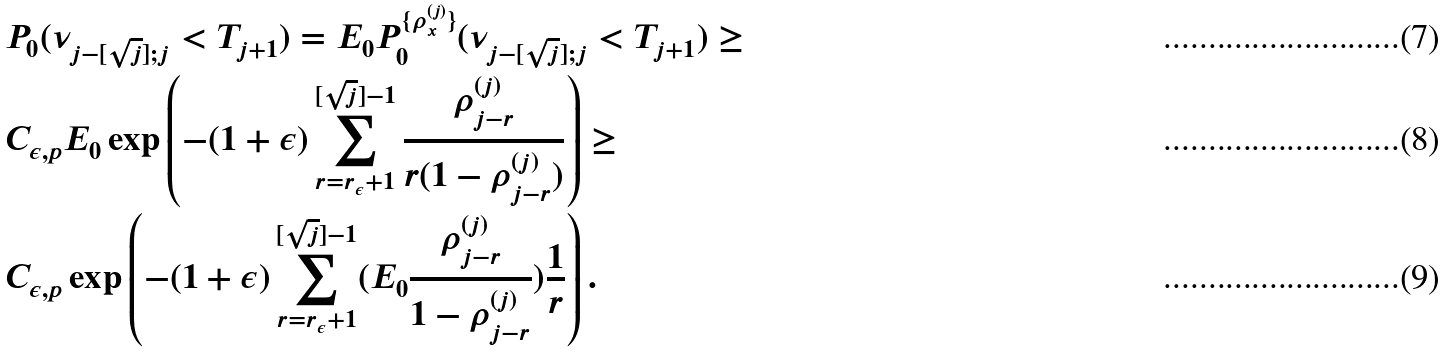<formula> <loc_0><loc_0><loc_500><loc_500>& P _ { 0 } ( \nu _ { j - [ \sqrt { j } ] ; j } < T _ { j + 1 } ) = E _ { 0 } P _ { 0 } ^ { \{ \rho _ { x } ^ { ( j ) } \} } ( \nu _ { j - [ \sqrt { j } ] ; j } < T _ { j + 1 } ) \geq \\ & C _ { \epsilon , p } E _ { 0 } \exp \left ( - ( 1 + \epsilon ) \sum _ { r = r _ { \epsilon } + 1 } ^ { [ \sqrt { j } ] - 1 } \frac { \rho _ { j - r } ^ { ( j ) } } { r ( 1 - \rho _ { j - r } ^ { ( j ) } ) } \right ) \geq \\ & C _ { \epsilon , p } \exp \left ( - ( 1 + \epsilon ) \sum _ { r = r _ { \epsilon } + 1 } ^ { [ \sqrt { j } ] - 1 } ( E _ { 0 } \frac { \rho _ { j - r } ^ { ( j ) } } { 1 - \rho _ { j - r } ^ { ( j ) } } ) \frac { 1 } { r } \right ) .</formula> 